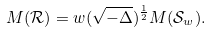<formula> <loc_0><loc_0><loc_500><loc_500>M ( \mathcal { R } ) = w ( \sqrt { - \Delta } ) ^ { \frac { 1 } { 2 } } M ( \mathcal { S } _ { w } ) .</formula> 